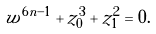<formula> <loc_0><loc_0><loc_500><loc_500>w ^ { 6 n - 1 } + z _ { 0 } ^ { 3 } + z _ { 1 } ^ { 2 } = 0 .</formula> 